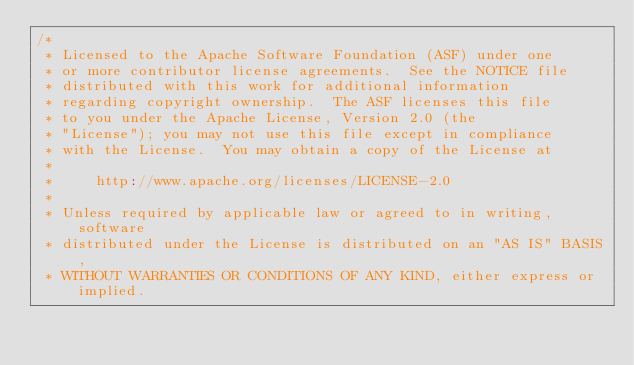Convert code to text. <code><loc_0><loc_0><loc_500><loc_500><_Scala_>/*
 * Licensed to the Apache Software Foundation (ASF) under one
 * or more contributor license agreements.  See the NOTICE file
 * distributed with this work for additional information
 * regarding copyright ownership.  The ASF licenses this file
 * to you under the Apache License, Version 2.0 (the
 * "License"); you may not use this file except in compliance
 * with the License.  You may obtain a copy of the License at
 *
 *     http://www.apache.org/licenses/LICENSE-2.0
 *
 * Unless required by applicable law or agreed to in writing, software
 * distributed under the License is distributed on an "AS IS" BASIS,
 * WITHOUT WARRANTIES OR CONDITIONS OF ANY KIND, either express or implied.</code> 